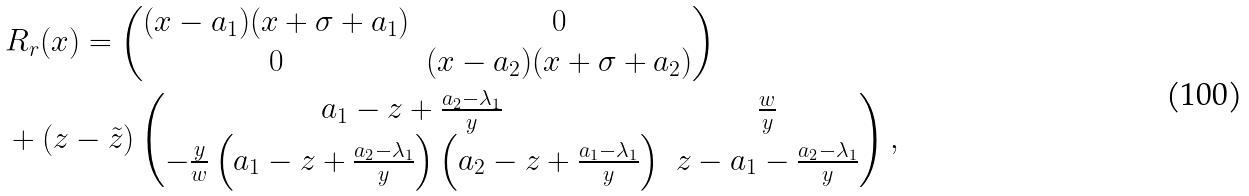Convert formula to latex. <formula><loc_0><loc_0><loc_500><loc_500>& R _ { r } ( x ) = \begin{pmatrix} ( x - a _ { 1 } ) ( x + \sigma + a _ { 1 } ) & 0 \\ 0 & ( x - a _ { 2 } ) ( x + \sigma + a _ { 2 } ) \end{pmatrix} \\ & + ( z - \tilde { z } ) \begin{pmatrix} a _ { 1 } - z + \frac { a _ { 2 } - \lambda _ { 1 } } { y } & \frac { w } { y } \\ - \frac { y } { w } \left ( a _ { 1 } - z + \frac { a _ { 2 } - \lambda _ { 1 } } { y } \right ) \left ( a _ { 2 } - z + \frac { a _ { 1 } - \lambda _ { 1 } } { y } \right ) & z - a _ { 1 } - \frac { a _ { 2 } - \lambda _ { 1 } } { y } \end{pmatrix} ,</formula> 